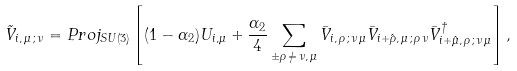<formula> <loc_0><loc_0><loc_500><loc_500>\tilde { V } _ { i , \, \mu \, ; \, \nu } = P r o j _ { S U ( 3 ) } \left [ ( 1 - \alpha _ { 2 } ) U _ { i , \mu } + \frac { \alpha _ { 2 } } { 4 } \sum _ { \pm \rho \, \neq \, \nu , \, \mu } \bar { V } _ { i , \, \rho \, ; \, \nu \, \mu } \bar { V } _ { i + \hat { \rho } , \, \mu \, ; \, \rho \, \nu } \bar { V } ^ { \dag } _ { i + \hat { \mu } , \, \rho \, ; \, \nu \, \mu } \right ] ,</formula> 